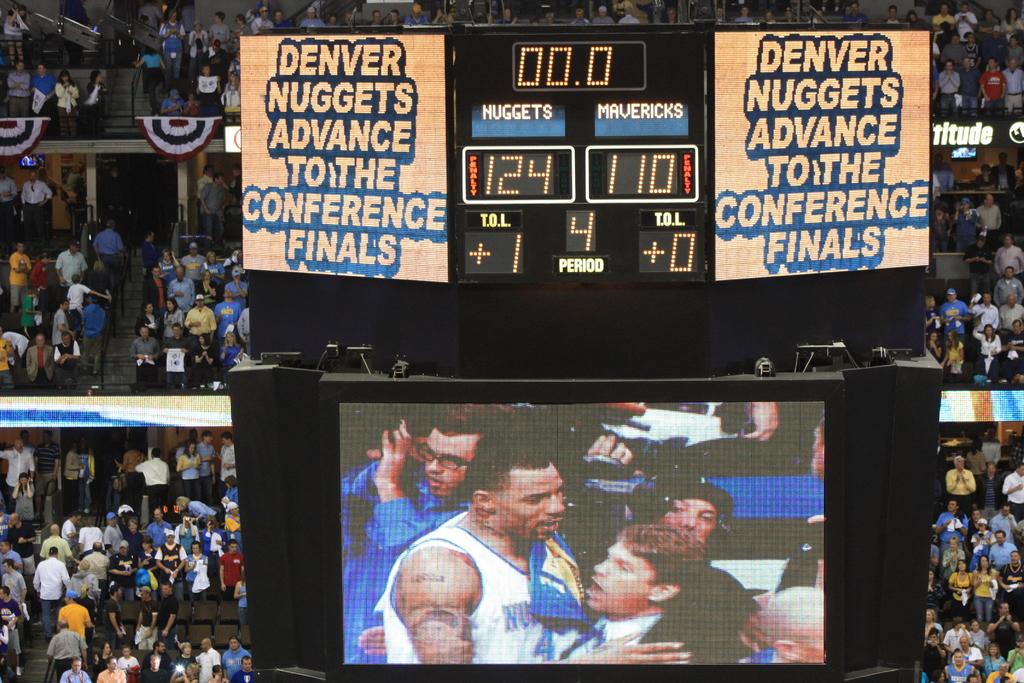Where is the nuggets from?
Your response must be concise. Denver. What is the nuggets score?
Provide a succinct answer. 124. 